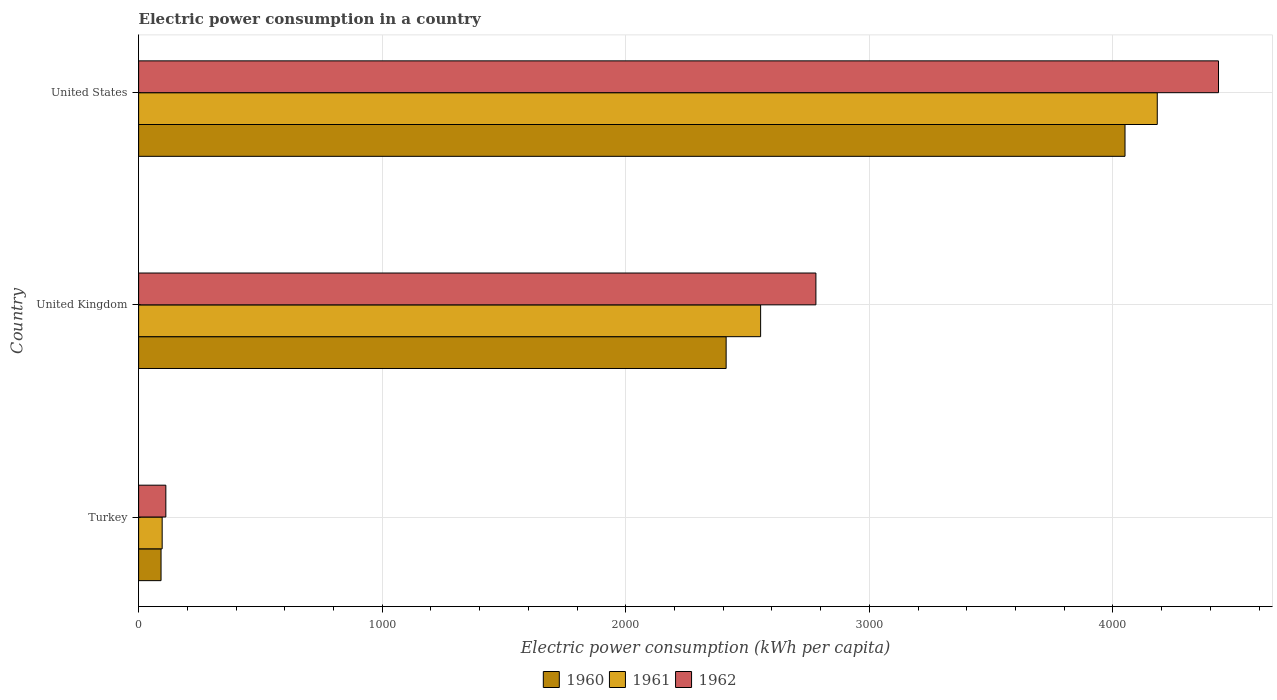How many different coloured bars are there?
Make the answer very short. 3. How many groups of bars are there?
Keep it short and to the point. 3. How many bars are there on the 2nd tick from the top?
Your answer should be very brief. 3. How many bars are there on the 2nd tick from the bottom?
Make the answer very short. 3. In how many cases, is the number of bars for a given country not equal to the number of legend labels?
Provide a short and direct response. 0. What is the electric power consumption in in 1962 in United Kingdom?
Provide a succinct answer. 2780.66. Across all countries, what is the maximum electric power consumption in in 1962?
Offer a terse response. 4433.61. Across all countries, what is the minimum electric power consumption in in 1962?
Make the answer very short. 111.76. In which country was the electric power consumption in in 1961 minimum?
Provide a succinct answer. Turkey. What is the total electric power consumption in in 1961 in the graph?
Offer a very short reply. 6832.51. What is the difference between the electric power consumption in in 1962 in Turkey and that in United States?
Keep it short and to the point. -4321.85. What is the difference between the electric power consumption in in 1962 in United Kingdom and the electric power consumption in in 1960 in United States?
Offer a very short reply. -1269.13. What is the average electric power consumption in in 1962 per country?
Your answer should be very brief. 2442.01. What is the difference between the electric power consumption in in 1960 and electric power consumption in in 1962 in United Kingdom?
Give a very brief answer. -368.52. In how many countries, is the electric power consumption in in 1962 greater than 2600 kWh per capita?
Your answer should be very brief. 2. What is the ratio of the electric power consumption in in 1962 in Turkey to that in United Kingdom?
Your answer should be compact. 0.04. Is the electric power consumption in in 1961 in United Kingdom less than that in United States?
Give a very brief answer. Yes. Is the difference between the electric power consumption in in 1960 in Turkey and United Kingdom greater than the difference between the electric power consumption in in 1962 in Turkey and United Kingdom?
Keep it short and to the point. Yes. What is the difference between the highest and the second highest electric power consumption in in 1961?
Offer a very short reply. 1628.48. What is the difference between the highest and the lowest electric power consumption in in 1961?
Offer a very short reply. 4085.54. In how many countries, is the electric power consumption in in 1960 greater than the average electric power consumption in in 1960 taken over all countries?
Your response must be concise. 2. What does the 3rd bar from the top in United States represents?
Keep it short and to the point. 1960. Is it the case that in every country, the sum of the electric power consumption in in 1962 and electric power consumption in in 1961 is greater than the electric power consumption in in 1960?
Your response must be concise. Yes. How many bars are there?
Your response must be concise. 9. Are all the bars in the graph horizontal?
Keep it short and to the point. Yes. How many countries are there in the graph?
Offer a very short reply. 3. Does the graph contain grids?
Offer a terse response. Yes. Where does the legend appear in the graph?
Make the answer very short. Bottom center. How many legend labels are there?
Keep it short and to the point. 3. What is the title of the graph?
Ensure brevity in your answer.  Electric power consumption in a country. What is the label or title of the X-axis?
Your answer should be compact. Electric power consumption (kWh per capita). What is the Electric power consumption (kWh per capita) of 1960 in Turkey?
Ensure brevity in your answer.  92.04. What is the Electric power consumption (kWh per capita) in 1961 in Turkey?
Provide a short and direct response. 96.64. What is the Electric power consumption (kWh per capita) of 1962 in Turkey?
Give a very brief answer. 111.76. What is the Electric power consumption (kWh per capita) in 1960 in United Kingdom?
Keep it short and to the point. 2412.14. What is the Electric power consumption (kWh per capita) in 1961 in United Kingdom?
Your answer should be very brief. 2553.69. What is the Electric power consumption (kWh per capita) of 1962 in United Kingdom?
Offer a very short reply. 2780.66. What is the Electric power consumption (kWh per capita) in 1960 in United States?
Offer a very short reply. 4049.79. What is the Electric power consumption (kWh per capita) in 1961 in United States?
Offer a terse response. 4182.18. What is the Electric power consumption (kWh per capita) of 1962 in United States?
Keep it short and to the point. 4433.61. Across all countries, what is the maximum Electric power consumption (kWh per capita) of 1960?
Your response must be concise. 4049.79. Across all countries, what is the maximum Electric power consumption (kWh per capita) of 1961?
Your answer should be very brief. 4182.18. Across all countries, what is the maximum Electric power consumption (kWh per capita) of 1962?
Your response must be concise. 4433.61. Across all countries, what is the minimum Electric power consumption (kWh per capita) in 1960?
Keep it short and to the point. 92.04. Across all countries, what is the minimum Electric power consumption (kWh per capita) in 1961?
Your answer should be very brief. 96.64. Across all countries, what is the minimum Electric power consumption (kWh per capita) of 1962?
Offer a very short reply. 111.76. What is the total Electric power consumption (kWh per capita) of 1960 in the graph?
Your answer should be very brief. 6553.96. What is the total Electric power consumption (kWh per capita) in 1961 in the graph?
Provide a succinct answer. 6832.51. What is the total Electric power consumption (kWh per capita) in 1962 in the graph?
Keep it short and to the point. 7326.02. What is the difference between the Electric power consumption (kWh per capita) of 1960 in Turkey and that in United Kingdom?
Offer a terse response. -2320.1. What is the difference between the Electric power consumption (kWh per capita) in 1961 in Turkey and that in United Kingdom?
Offer a very short reply. -2457.06. What is the difference between the Electric power consumption (kWh per capita) in 1962 in Turkey and that in United Kingdom?
Your answer should be very brief. -2668.9. What is the difference between the Electric power consumption (kWh per capita) in 1960 in Turkey and that in United States?
Your response must be concise. -3957.75. What is the difference between the Electric power consumption (kWh per capita) of 1961 in Turkey and that in United States?
Ensure brevity in your answer.  -4085.54. What is the difference between the Electric power consumption (kWh per capita) of 1962 in Turkey and that in United States?
Offer a terse response. -4321.85. What is the difference between the Electric power consumption (kWh per capita) in 1960 in United Kingdom and that in United States?
Your answer should be very brief. -1637.65. What is the difference between the Electric power consumption (kWh per capita) of 1961 in United Kingdom and that in United States?
Provide a succinct answer. -1628.48. What is the difference between the Electric power consumption (kWh per capita) in 1962 in United Kingdom and that in United States?
Your answer should be very brief. -1652.95. What is the difference between the Electric power consumption (kWh per capita) in 1960 in Turkey and the Electric power consumption (kWh per capita) in 1961 in United Kingdom?
Provide a short and direct response. -2461.65. What is the difference between the Electric power consumption (kWh per capita) in 1960 in Turkey and the Electric power consumption (kWh per capita) in 1962 in United Kingdom?
Offer a very short reply. -2688.62. What is the difference between the Electric power consumption (kWh per capita) in 1961 in Turkey and the Electric power consumption (kWh per capita) in 1962 in United Kingdom?
Offer a very short reply. -2684.02. What is the difference between the Electric power consumption (kWh per capita) in 1960 in Turkey and the Electric power consumption (kWh per capita) in 1961 in United States?
Provide a short and direct response. -4090.14. What is the difference between the Electric power consumption (kWh per capita) in 1960 in Turkey and the Electric power consumption (kWh per capita) in 1962 in United States?
Offer a very short reply. -4341.57. What is the difference between the Electric power consumption (kWh per capita) of 1961 in Turkey and the Electric power consumption (kWh per capita) of 1962 in United States?
Keep it short and to the point. -4336.97. What is the difference between the Electric power consumption (kWh per capita) of 1960 in United Kingdom and the Electric power consumption (kWh per capita) of 1961 in United States?
Your response must be concise. -1770.04. What is the difference between the Electric power consumption (kWh per capita) in 1960 in United Kingdom and the Electric power consumption (kWh per capita) in 1962 in United States?
Ensure brevity in your answer.  -2021.47. What is the difference between the Electric power consumption (kWh per capita) of 1961 in United Kingdom and the Electric power consumption (kWh per capita) of 1962 in United States?
Ensure brevity in your answer.  -1879.91. What is the average Electric power consumption (kWh per capita) in 1960 per country?
Ensure brevity in your answer.  2184.65. What is the average Electric power consumption (kWh per capita) in 1961 per country?
Make the answer very short. 2277.5. What is the average Electric power consumption (kWh per capita) in 1962 per country?
Your response must be concise. 2442.01. What is the difference between the Electric power consumption (kWh per capita) in 1960 and Electric power consumption (kWh per capita) in 1961 in Turkey?
Your response must be concise. -4.6. What is the difference between the Electric power consumption (kWh per capita) in 1960 and Electric power consumption (kWh per capita) in 1962 in Turkey?
Give a very brief answer. -19.72. What is the difference between the Electric power consumption (kWh per capita) in 1961 and Electric power consumption (kWh per capita) in 1962 in Turkey?
Provide a short and direct response. -15.12. What is the difference between the Electric power consumption (kWh per capita) of 1960 and Electric power consumption (kWh per capita) of 1961 in United Kingdom?
Make the answer very short. -141.56. What is the difference between the Electric power consumption (kWh per capita) of 1960 and Electric power consumption (kWh per capita) of 1962 in United Kingdom?
Ensure brevity in your answer.  -368.52. What is the difference between the Electric power consumption (kWh per capita) of 1961 and Electric power consumption (kWh per capita) of 1962 in United Kingdom?
Provide a short and direct response. -226.96. What is the difference between the Electric power consumption (kWh per capita) in 1960 and Electric power consumption (kWh per capita) in 1961 in United States?
Ensure brevity in your answer.  -132.39. What is the difference between the Electric power consumption (kWh per capita) in 1960 and Electric power consumption (kWh per capita) in 1962 in United States?
Make the answer very short. -383.82. What is the difference between the Electric power consumption (kWh per capita) in 1961 and Electric power consumption (kWh per capita) in 1962 in United States?
Offer a very short reply. -251.43. What is the ratio of the Electric power consumption (kWh per capita) in 1960 in Turkey to that in United Kingdom?
Keep it short and to the point. 0.04. What is the ratio of the Electric power consumption (kWh per capita) of 1961 in Turkey to that in United Kingdom?
Offer a very short reply. 0.04. What is the ratio of the Electric power consumption (kWh per capita) of 1962 in Turkey to that in United Kingdom?
Give a very brief answer. 0.04. What is the ratio of the Electric power consumption (kWh per capita) in 1960 in Turkey to that in United States?
Make the answer very short. 0.02. What is the ratio of the Electric power consumption (kWh per capita) of 1961 in Turkey to that in United States?
Provide a succinct answer. 0.02. What is the ratio of the Electric power consumption (kWh per capita) in 1962 in Turkey to that in United States?
Your response must be concise. 0.03. What is the ratio of the Electric power consumption (kWh per capita) of 1960 in United Kingdom to that in United States?
Give a very brief answer. 0.6. What is the ratio of the Electric power consumption (kWh per capita) of 1961 in United Kingdom to that in United States?
Provide a short and direct response. 0.61. What is the ratio of the Electric power consumption (kWh per capita) of 1962 in United Kingdom to that in United States?
Your response must be concise. 0.63. What is the difference between the highest and the second highest Electric power consumption (kWh per capita) in 1960?
Give a very brief answer. 1637.65. What is the difference between the highest and the second highest Electric power consumption (kWh per capita) of 1961?
Give a very brief answer. 1628.48. What is the difference between the highest and the second highest Electric power consumption (kWh per capita) of 1962?
Your response must be concise. 1652.95. What is the difference between the highest and the lowest Electric power consumption (kWh per capita) in 1960?
Your response must be concise. 3957.75. What is the difference between the highest and the lowest Electric power consumption (kWh per capita) in 1961?
Provide a succinct answer. 4085.54. What is the difference between the highest and the lowest Electric power consumption (kWh per capita) of 1962?
Your response must be concise. 4321.85. 